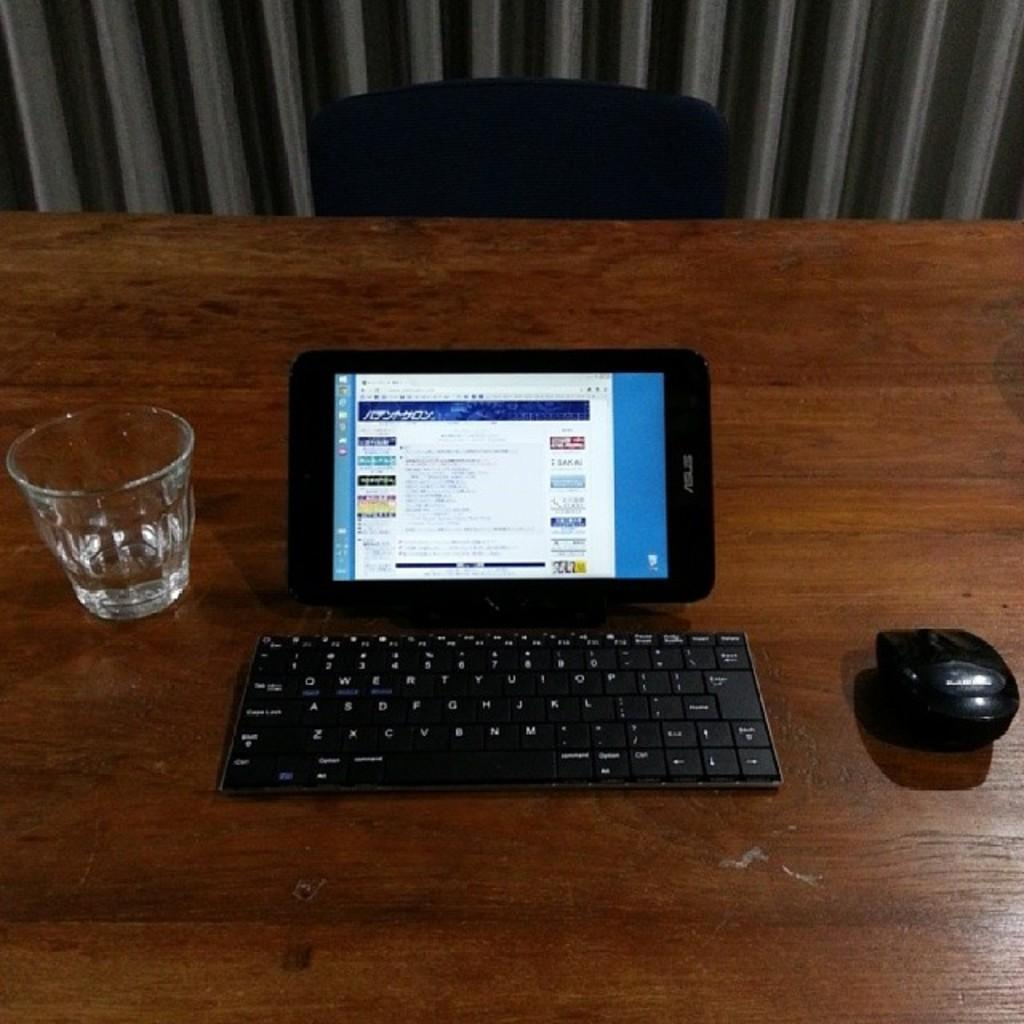What piece of furniture is present in the image? There is a table in the image. What electronic device is on the table? There is a tab (likely a tablet device) on the table. What input devices are visible in the image? There is a wireless keyboard and a wireless mouse in the image. What type of beverage container is on the table? There is a water glass on the table. What type of seating is present in the image? There is a chair in the image. What can be seen in the background of the image? There is a curtain in the background of the image. What type of pet is sitting on the table in the image? There is no pet present in the image. How does the earth interact with the wireless keyboard in the image? The earth does not interact with the wireless keyboard in the image; it is an inanimate object. 